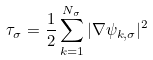<formula> <loc_0><loc_0><loc_500><loc_500>\tau _ { \sigma } = \frac { 1 } { 2 } \sum _ { k = 1 } ^ { N _ { \sigma } } | \nabla \psi _ { k , \sigma } | ^ { 2 }</formula> 